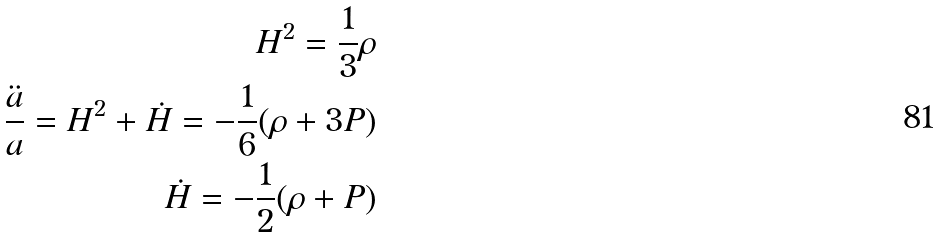<formula> <loc_0><loc_0><loc_500><loc_500>H ^ { 2 } = \frac { 1 } { 3 } \rho \\ \frac { \ddot { a } } { a } = H ^ { 2 } + \dot { H } = - \frac { 1 } { 6 } ( \rho + 3 P ) \\ \dot { H } = - \frac { 1 } { 2 } ( \rho + P )</formula> 